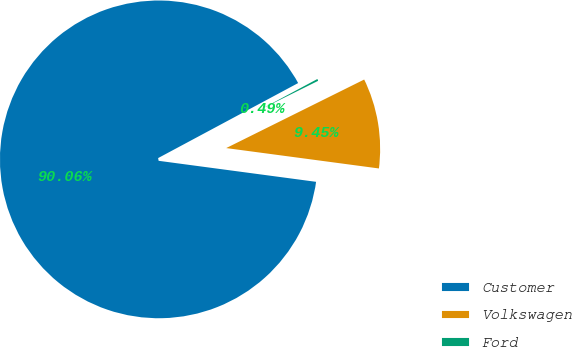<chart> <loc_0><loc_0><loc_500><loc_500><pie_chart><fcel>Customer<fcel>Volkswagen<fcel>Ford<nl><fcel>90.06%<fcel>9.45%<fcel>0.49%<nl></chart> 